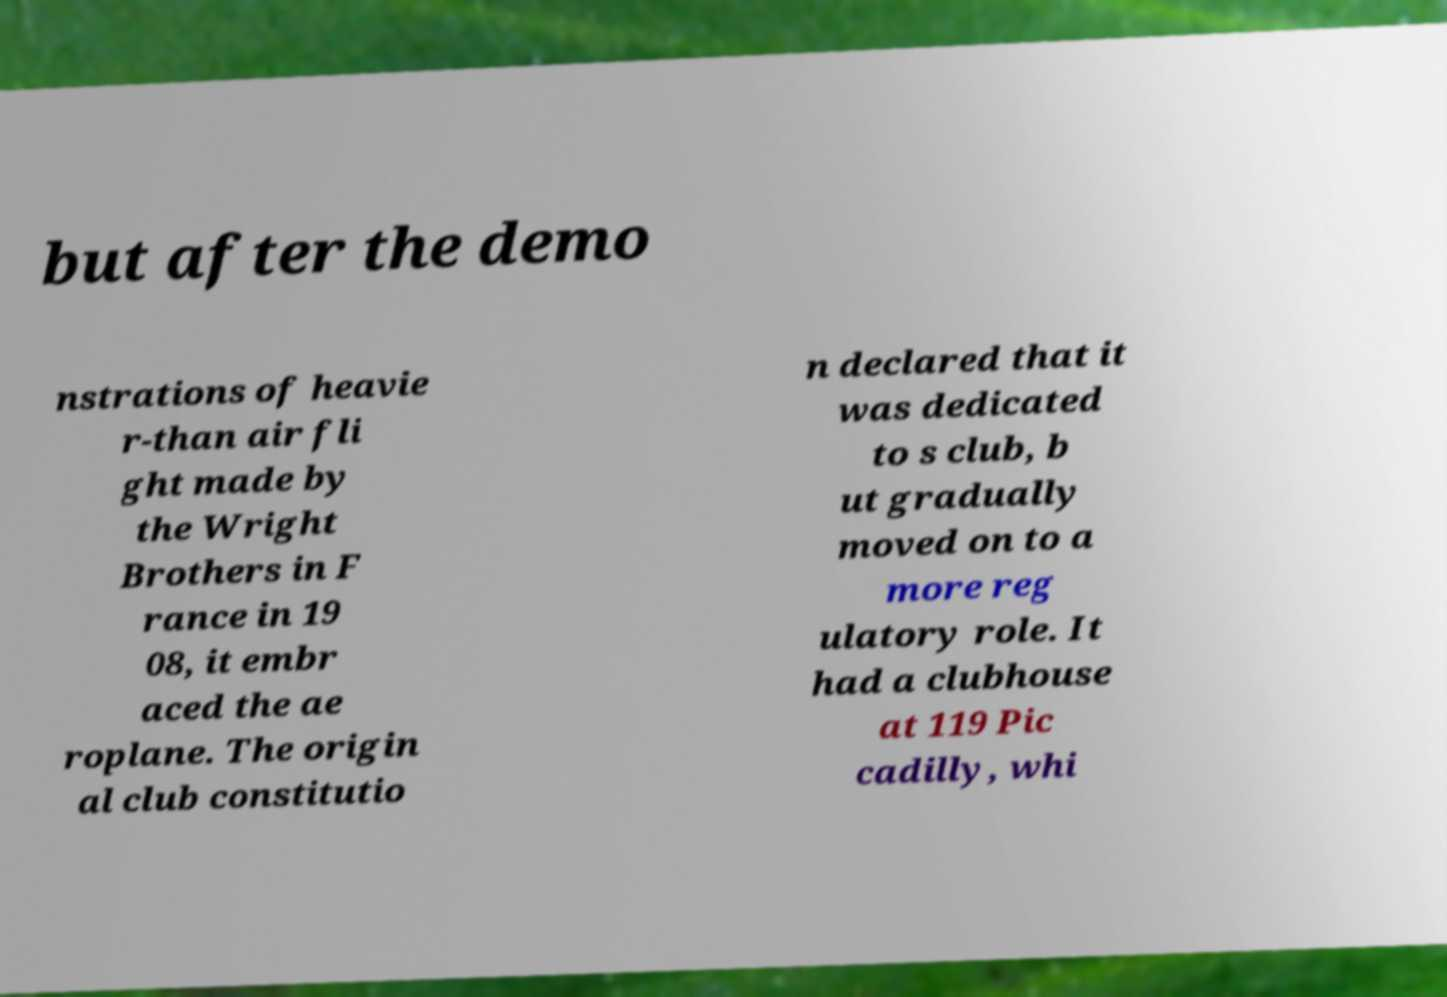Could you assist in decoding the text presented in this image and type it out clearly? but after the demo nstrations of heavie r-than air fli ght made by the Wright Brothers in F rance in 19 08, it embr aced the ae roplane. The origin al club constitutio n declared that it was dedicated to s club, b ut gradually moved on to a more reg ulatory role. It had a clubhouse at 119 Pic cadilly, whi 